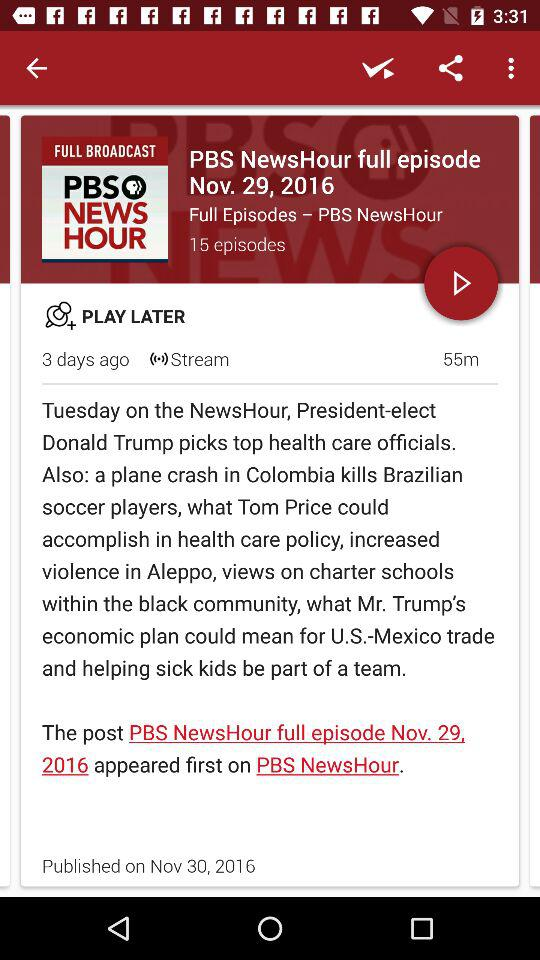What is the date of the recently published episode? The date of the recently published episode is November 29, 2016. 